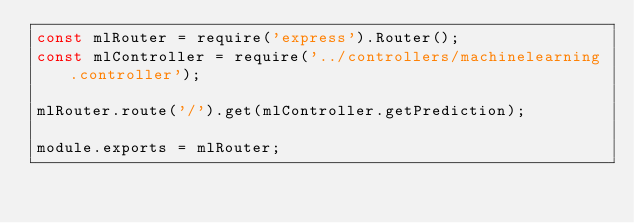<code> <loc_0><loc_0><loc_500><loc_500><_JavaScript_>const mlRouter = require('express').Router();
const mlController = require('../controllers/machinelearning.controller');

mlRouter.route('/').get(mlController.getPrediction);

module.exports = mlRouter;</code> 